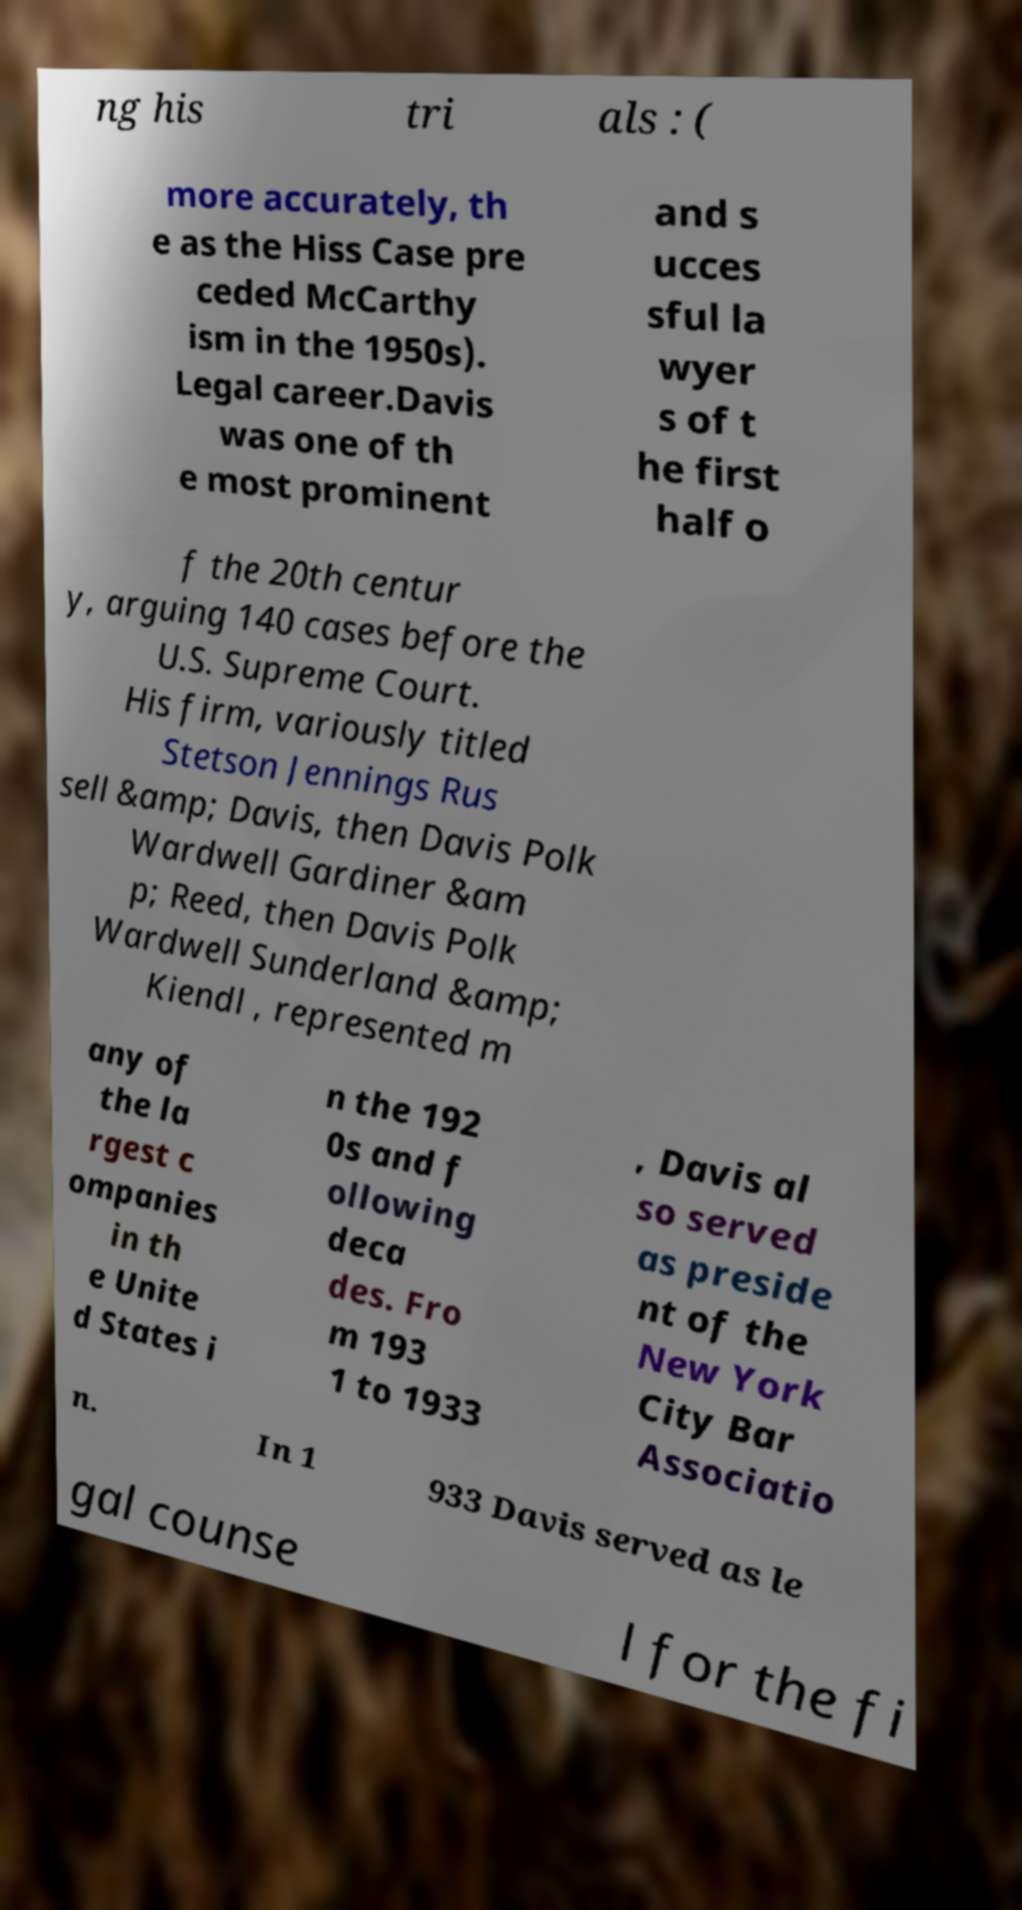Can you read and provide the text displayed in the image?This photo seems to have some interesting text. Can you extract and type it out for me? ng his tri als : ( more accurately, th e as the Hiss Case pre ceded McCarthy ism in the 1950s). Legal career.Davis was one of th e most prominent and s ucces sful la wyer s of t he first half o f the 20th centur y, arguing 140 cases before the U.S. Supreme Court. His firm, variously titled Stetson Jennings Rus sell &amp; Davis, then Davis Polk Wardwell Gardiner &am p; Reed, then Davis Polk Wardwell Sunderland &amp; Kiendl , represented m any of the la rgest c ompanies in th e Unite d States i n the 192 0s and f ollowing deca des. Fro m 193 1 to 1933 , Davis al so served as preside nt of the New York City Bar Associatio n. In 1 933 Davis served as le gal counse l for the fi 